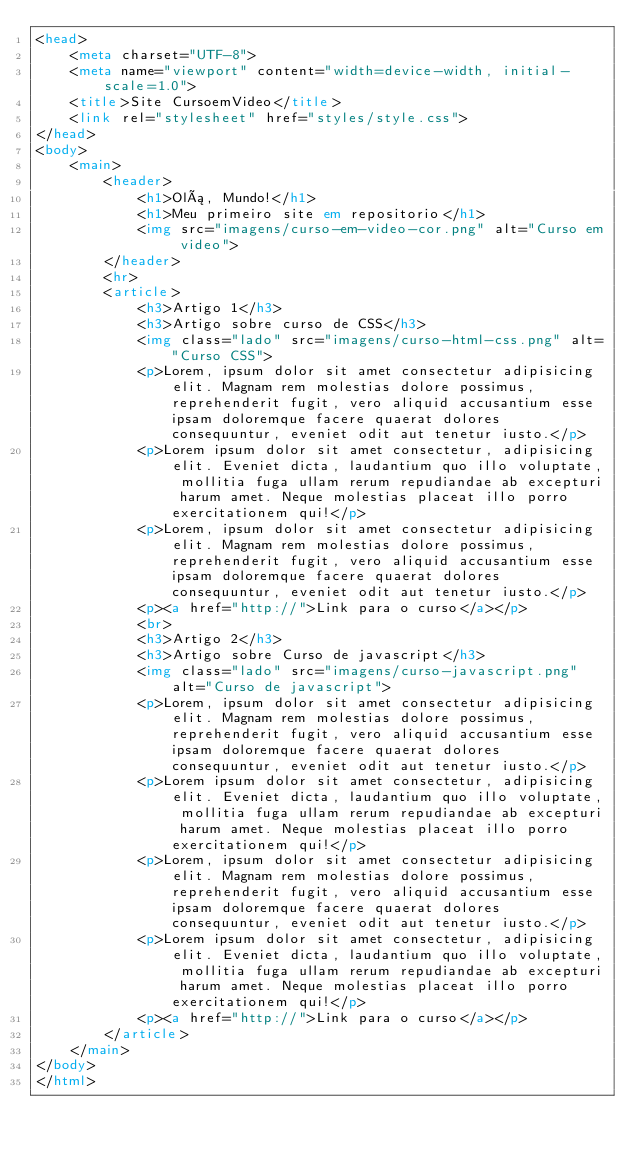<code> <loc_0><loc_0><loc_500><loc_500><_HTML_><head>
    <meta charset="UTF-8">
    <meta name="viewport" content="width=device-width, initial-scale=1.0">
    <title>Site CursoemVideo</title>
    <link rel="stylesheet" href="styles/style.css">
</head>
<body>
    <main>
        <header>
            <h1>Olá, Mundo!</h1>
            <h1>Meu primeiro site em repositorio</h1>
            <img src="imagens/curso-em-video-cor.png" alt="Curso em video">
        </header>
        <hr>
        <article>
            <h3>Artigo 1</h3>
            <h3>Artigo sobre curso de CSS</h3>
            <img class="lado" src="imagens/curso-html-css.png" alt="Curso CSS">
            <p>Lorem, ipsum dolor sit amet consectetur adipisicing elit. Magnam rem molestias dolore possimus, reprehenderit fugit, vero aliquid accusantium esse ipsam doloremque facere quaerat dolores consequuntur, eveniet odit aut tenetur iusto.</p>
            <p>Lorem ipsum dolor sit amet consectetur, adipisicing elit. Eveniet dicta, laudantium quo illo voluptate, mollitia fuga ullam rerum repudiandae ab excepturi harum amet. Neque molestias placeat illo porro exercitationem qui!</p>
            <p>Lorem, ipsum dolor sit amet consectetur adipisicing elit. Magnam rem molestias dolore possimus, reprehenderit fugit, vero aliquid accusantium esse ipsam doloremque facere quaerat dolores consequuntur, eveniet odit aut tenetur iusto.</p>
            <p><a href="http://">Link para o curso</a></p>
            <br>
            <h3>Artigo 2</h3>
            <h3>Artigo sobre Curso de javascript</h3>
            <img class="lado" src="imagens/curso-javascript.png" alt="Curso de javascript">
            <p>Lorem, ipsum dolor sit amet consectetur adipisicing elit. Magnam rem molestias dolore possimus, reprehenderit fugit, vero aliquid accusantium esse ipsam doloremque facere quaerat dolores consequuntur, eveniet odit aut tenetur iusto.</p>
            <p>Lorem ipsum dolor sit amet consectetur, adipisicing elit. Eveniet dicta, laudantium quo illo voluptate, mollitia fuga ullam rerum repudiandae ab excepturi harum amet. Neque molestias placeat illo porro exercitationem qui!</p>
            <p>Lorem, ipsum dolor sit amet consectetur adipisicing elit. Magnam rem molestias dolore possimus, reprehenderit fugit, vero aliquid accusantium esse ipsam doloremque facere quaerat dolores consequuntur, eveniet odit aut tenetur iusto.</p>
            <p>Lorem ipsum dolor sit amet consectetur, adipisicing elit. Eveniet dicta, laudantium quo illo voluptate, mollitia fuga ullam rerum repudiandae ab excepturi harum amet. Neque molestias placeat illo porro exercitationem qui!</p>
            <p><a href="http://">Link para o curso</a></p>
        </article>
    </main>
</body>
</html></code> 